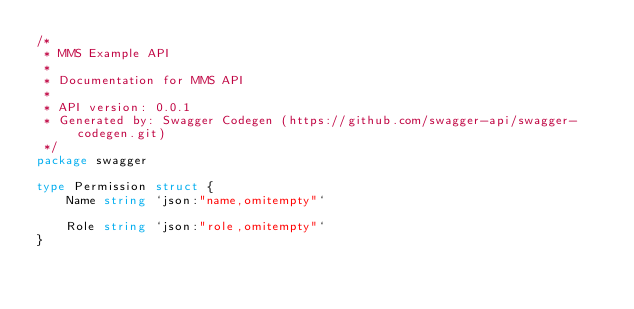Convert code to text. <code><loc_0><loc_0><loc_500><loc_500><_Go_>/*
 * MMS Example API
 *
 * Documentation for MMS API
 *
 * API version: 0.0.1
 * Generated by: Swagger Codegen (https://github.com/swagger-api/swagger-codegen.git)
 */
package swagger

type Permission struct {
	Name string `json:"name,omitempty"`

	Role string `json:"role,omitempty"`
}
</code> 